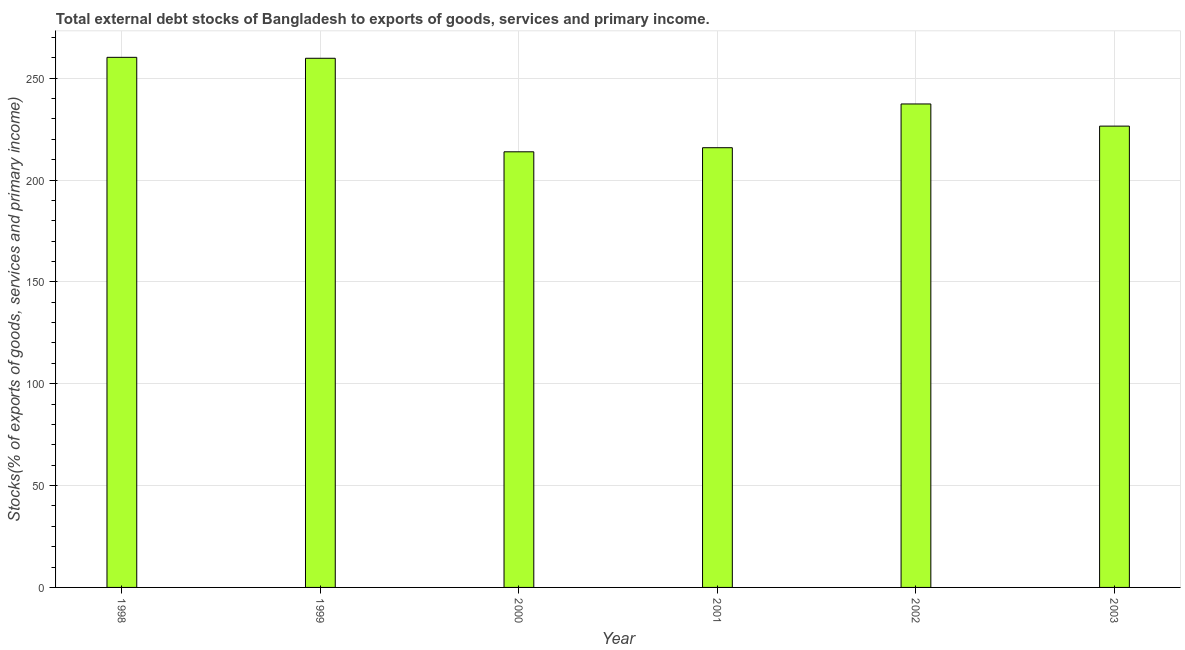Does the graph contain grids?
Give a very brief answer. Yes. What is the title of the graph?
Make the answer very short. Total external debt stocks of Bangladesh to exports of goods, services and primary income. What is the label or title of the Y-axis?
Offer a terse response. Stocks(% of exports of goods, services and primary income). What is the external debt stocks in 1999?
Your answer should be very brief. 259.78. Across all years, what is the maximum external debt stocks?
Provide a succinct answer. 260.24. Across all years, what is the minimum external debt stocks?
Ensure brevity in your answer.  213.86. In which year was the external debt stocks maximum?
Provide a short and direct response. 1998. What is the sum of the external debt stocks?
Provide a short and direct response. 1413.57. What is the difference between the external debt stocks in 2002 and 2003?
Make the answer very short. 10.88. What is the average external debt stocks per year?
Your answer should be compact. 235.59. What is the median external debt stocks?
Provide a short and direct response. 231.91. Do a majority of the years between 2002 and 2000 (inclusive) have external debt stocks greater than 230 %?
Keep it short and to the point. Yes. What is the ratio of the external debt stocks in 2000 to that in 2001?
Ensure brevity in your answer.  0.99. What is the difference between the highest and the second highest external debt stocks?
Make the answer very short. 0.46. Is the sum of the external debt stocks in 1998 and 2001 greater than the maximum external debt stocks across all years?
Your response must be concise. Yes. What is the difference between the highest and the lowest external debt stocks?
Your response must be concise. 46.38. How many years are there in the graph?
Keep it short and to the point. 6. What is the difference between two consecutive major ticks on the Y-axis?
Provide a short and direct response. 50. Are the values on the major ticks of Y-axis written in scientific E-notation?
Ensure brevity in your answer.  No. What is the Stocks(% of exports of goods, services and primary income) of 1998?
Make the answer very short. 260.24. What is the Stocks(% of exports of goods, services and primary income) in 1999?
Make the answer very short. 259.78. What is the Stocks(% of exports of goods, services and primary income) of 2000?
Your answer should be very brief. 213.86. What is the Stocks(% of exports of goods, services and primary income) in 2001?
Your answer should be very brief. 215.87. What is the Stocks(% of exports of goods, services and primary income) in 2002?
Make the answer very short. 237.35. What is the Stocks(% of exports of goods, services and primary income) in 2003?
Give a very brief answer. 226.47. What is the difference between the Stocks(% of exports of goods, services and primary income) in 1998 and 1999?
Keep it short and to the point. 0.46. What is the difference between the Stocks(% of exports of goods, services and primary income) in 1998 and 2000?
Provide a succinct answer. 46.38. What is the difference between the Stocks(% of exports of goods, services and primary income) in 1998 and 2001?
Offer a very short reply. 44.37. What is the difference between the Stocks(% of exports of goods, services and primary income) in 1998 and 2002?
Give a very brief answer. 22.89. What is the difference between the Stocks(% of exports of goods, services and primary income) in 1998 and 2003?
Make the answer very short. 33.77. What is the difference between the Stocks(% of exports of goods, services and primary income) in 1999 and 2000?
Your answer should be compact. 45.92. What is the difference between the Stocks(% of exports of goods, services and primary income) in 1999 and 2001?
Make the answer very short. 43.91. What is the difference between the Stocks(% of exports of goods, services and primary income) in 1999 and 2002?
Offer a terse response. 22.43. What is the difference between the Stocks(% of exports of goods, services and primary income) in 1999 and 2003?
Make the answer very short. 33.31. What is the difference between the Stocks(% of exports of goods, services and primary income) in 2000 and 2001?
Provide a short and direct response. -2.01. What is the difference between the Stocks(% of exports of goods, services and primary income) in 2000 and 2002?
Provide a short and direct response. -23.49. What is the difference between the Stocks(% of exports of goods, services and primary income) in 2000 and 2003?
Ensure brevity in your answer.  -12.61. What is the difference between the Stocks(% of exports of goods, services and primary income) in 2001 and 2002?
Make the answer very short. -21.48. What is the difference between the Stocks(% of exports of goods, services and primary income) in 2001 and 2003?
Keep it short and to the point. -10.6. What is the difference between the Stocks(% of exports of goods, services and primary income) in 2002 and 2003?
Offer a terse response. 10.88. What is the ratio of the Stocks(% of exports of goods, services and primary income) in 1998 to that in 2000?
Offer a very short reply. 1.22. What is the ratio of the Stocks(% of exports of goods, services and primary income) in 1998 to that in 2001?
Give a very brief answer. 1.21. What is the ratio of the Stocks(% of exports of goods, services and primary income) in 1998 to that in 2002?
Your answer should be compact. 1.1. What is the ratio of the Stocks(% of exports of goods, services and primary income) in 1998 to that in 2003?
Offer a very short reply. 1.15. What is the ratio of the Stocks(% of exports of goods, services and primary income) in 1999 to that in 2000?
Your answer should be very brief. 1.22. What is the ratio of the Stocks(% of exports of goods, services and primary income) in 1999 to that in 2001?
Keep it short and to the point. 1.2. What is the ratio of the Stocks(% of exports of goods, services and primary income) in 1999 to that in 2002?
Ensure brevity in your answer.  1.09. What is the ratio of the Stocks(% of exports of goods, services and primary income) in 1999 to that in 2003?
Ensure brevity in your answer.  1.15. What is the ratio of the Stocks(% of exports of goods, services and primary income) in 2000 to that in 2001?
Provide a short and direct response. 0.99. What is the ratio of the Stocks(% of exports of goods, services and primary income) in 2000 to that in 2002?
Offer a very short reply. 0.9. What is the ratio of the Stocks(% of exports of goods, services and primary income) in 2000 to that in 2003?
Your answer should be very brief. 0.94. What is the ratio of the Stocks(% of exports of goods, services and primary income) in 2001 to that in 2002?
Offer a very short reply. 0.91. What is the ratio of the Stocks(% of exports of goods, services and primary income) in 2001 to that in 2003?
Provide a short and direct response. 0.95. What is the ratio of the Stocks(% of exports of goods, services and primary income) in 2002 to that in 2003?
Your answer should be very brief. 1.05. 